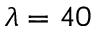<formula> <loc_0><loc_0><loc_500><loc_500>\lambda = 4 0</formula> 